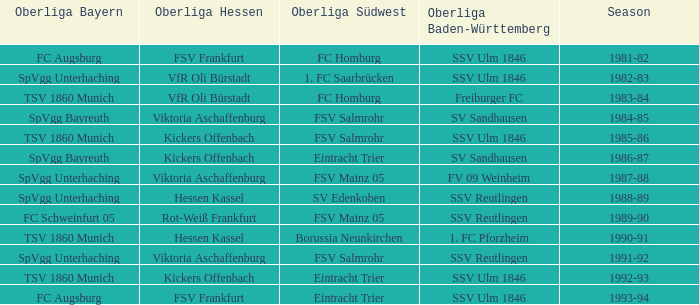In the 1993-94 timeframe, which oberliga baden-württemberg includes an oberliga hessen for fsv frankfurt? SSV Ulm 1846. 